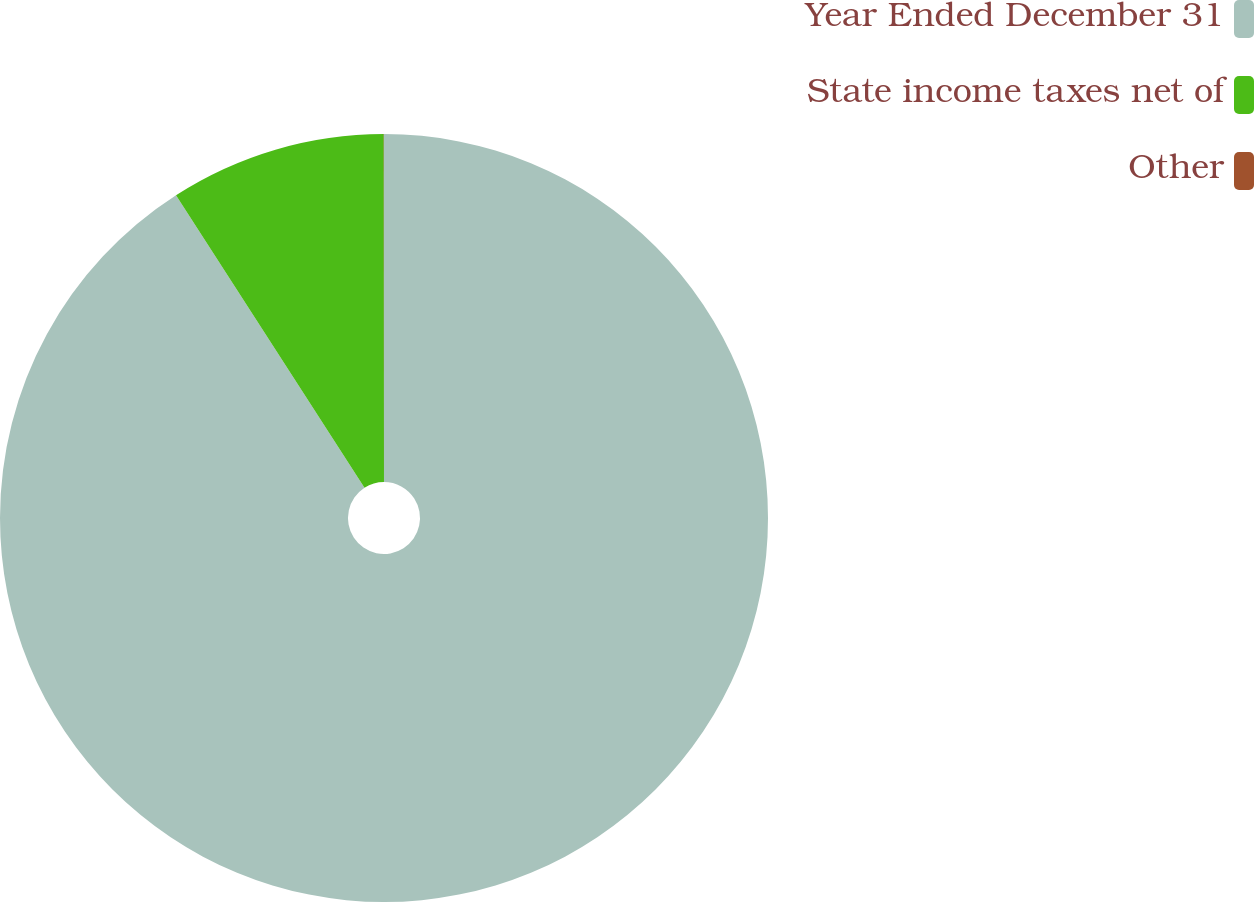Convert chart. <chart><loc_0><loc_0><loc_500><loc_500><pie_chart><fcel>Year Ended December 31<fcel>State income taxes net of<fcel>Other<nl><fcel>90.89%<fcel>9.1%<fcel>0.01%<nl></chart> 